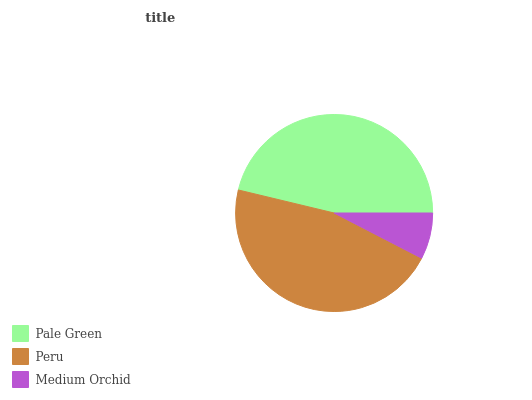Is Medium Orchid the minimum?
Answer yes or no. Yes. Is Pale Green the maximum?
Answer yes or no. Yes. Is Peru the minimum?
Answer yes or no. No. Is Peru the maximum?
Answer yes or no. No. Is Pale Green greater than Peru?
Answer yes or no. Yes. Is Peru less than Pale Green?
Answer yes or no. Yes. Is Peru greater than Pale Green?
Answer yes or no. No. Is Pale Green less than Peru?
Answer yes or no. No. Is Peru the high median?
Answer yes or no. Yes. Is Peru the low median?
Answer yes or no. Yes. Is Medium Orchid the high median?
Answer yes or no. No. Is Medium Orchid the low median?
Answer yes or no. No. 